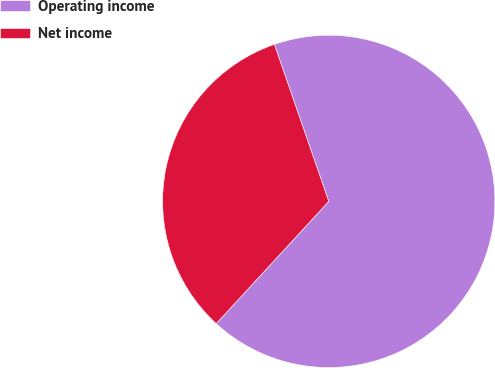<chart> <loc_0><loc_0><loc_500><loc_500><pie_chart><fcel>Operating income<fcel>Net income<nl><fcel>67.15%<fcel>32.85%<nl></chart> 